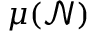Convert formula to latex. <formula><loc_0><loc_0><loc_500><loc_500>\mu ( \mathcal { N } )</formula> 